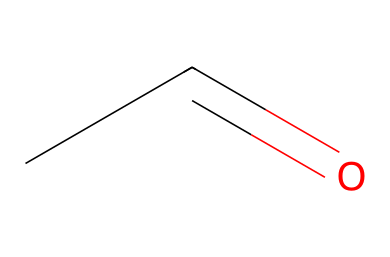What is the name of the chemical represented by this structure? The SMILES representation "CC=O" corresponds to acetaldehyde, which is an aldehyde due to the presence of the carbonyl group (C=O) at the terminal position of the carbon chain.
Answer: acetaldehyde How many carbon atoms are present in this molecule? The SMILES notation "CC=O" indicates that there are two carbon atoms connected in a chain (the first carbon "C" connected to the second "C"), making a total of two carbon atoms.
Answer: 2 What functional group is present in acetaldehyde? In the given SMILES "CC=O", the presence of "C=O" indicates that acetaldehyde contains a carbonyl group, which is characteristic of aldehydes. Thus, the functional group is an aldehyde.
Answer: carbonyl What is the degree of unsaturation in acetaldehyde? The degree of unsaturation can be calculated based on the structure: the presence of one carbon-carbon double bond (C=C) or one carbonyl group (C=O) counts as one degree of unsaturation. In acetaldehyde, there is one carbonyl group, which indicates a degree of unsaturation of one.
Answer: 1 Which part of the structure determines its reactivity as an aldehyde? The reactivity of acetaldehyde as an aldehyde is determined by the carbonyl group (C=O) at the end of the carbon chain. Aldehydes generally undergo oxidation and can react with nucleophiles due to the partial positive charge on the carbon of the carbonyl group.
Answer: carbonyl group What type of reaction is acetaldehyde primarily involved in during wine fermentation? Acetaldehyde primarily undergoes fermentation reactions, where it can be produced from the oxidation of ethanol. This transformation illustrates its integral role in the process by which sugars are converted into alcohol and other compounds during fermentation.
Answer: oxidation 